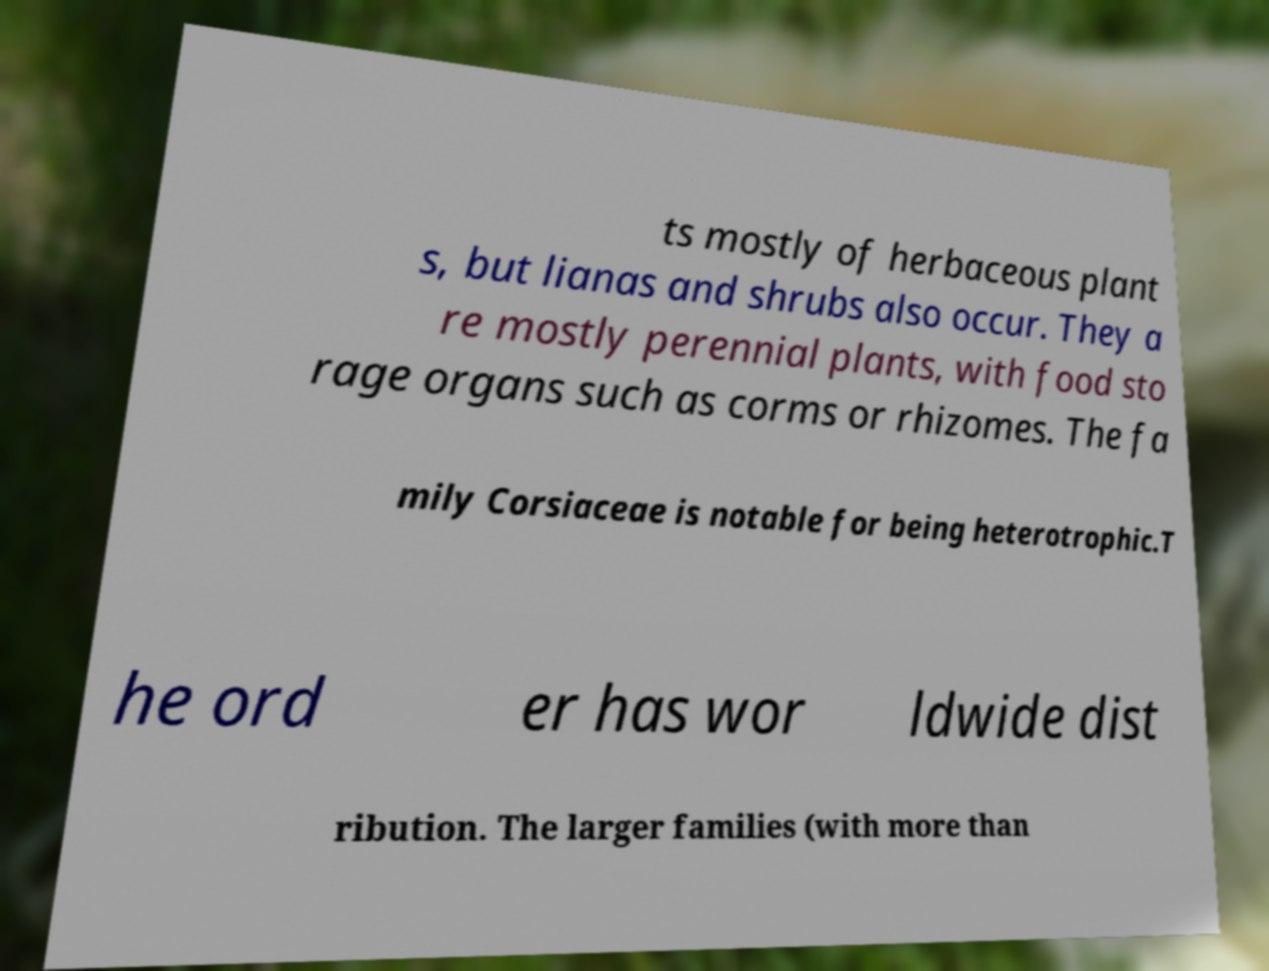Can you read and provide the text displayed in the image?This photo seems to have some interesting text. Can you extract and type it out for me? ts mostly of herbaceous plant s, but lianas and shrubs also occur. They a re mostly perennial plants, with food sto rage organs such as corms or rhizomes. The fa mily Corsiaceae is notable for being heterotrophic.T he ord er has wor ldwide dist ribution. The larger families (with more than 